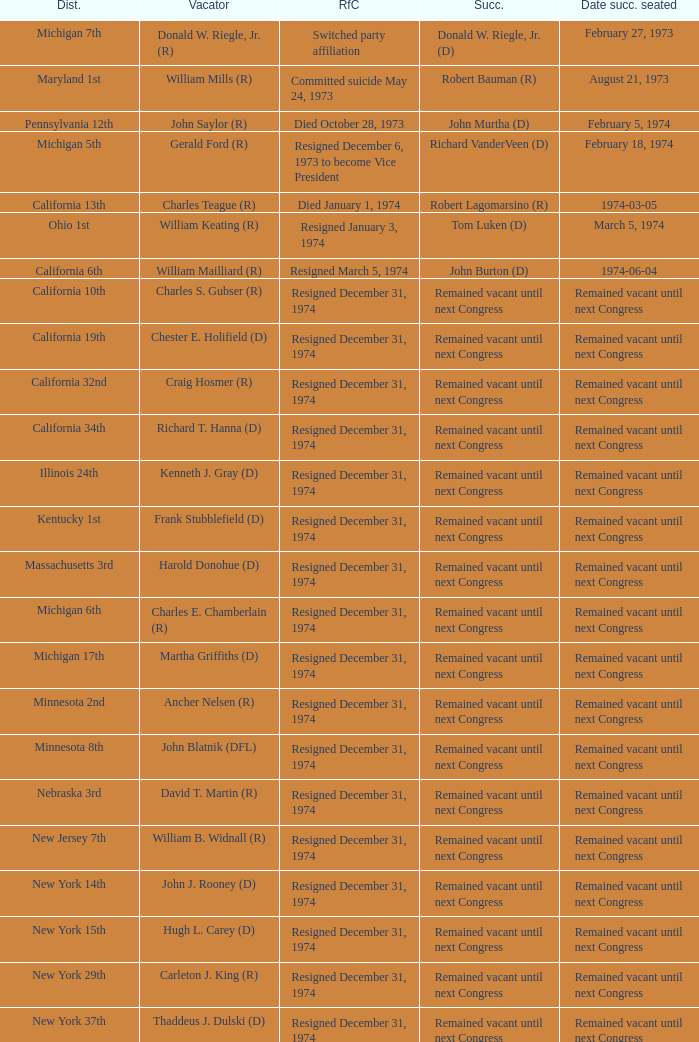What was the district when the reason for change was died January 1, 1974? California 13th. 